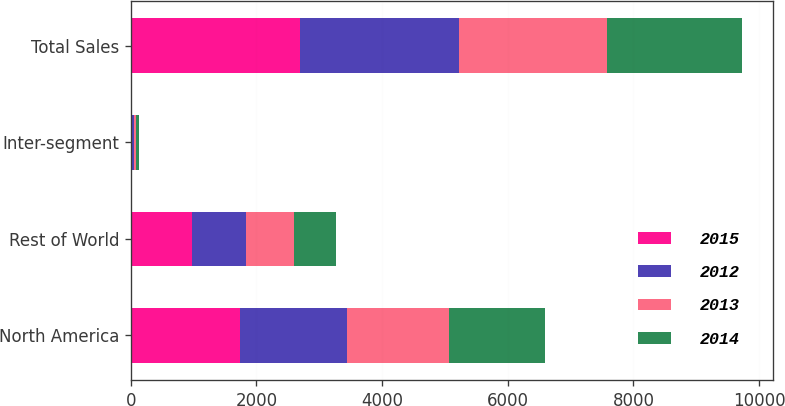Convert chart to OTSL. <chart><loc_0><loc_0><loc_500><loc_500><stacked_bar_chart><ecel><fcel>North America<fcel>Rest of World<fcel>Inter-segment<fcel>Total Sales<nl><fcel>2015<fcel>1743.2<fcel>965.6<fcel>22.9<fcel>2685.9<nl><fcel>2012<fcel>1703<fcel>866.1<fcel>32.6<fcel>2536.5<nl><fcel>2013<fcel>1621.7<fcel>768.3<fcel>34<fcel>2356<nl><fcel>2014<fcel>1520<fcel>668<fcel>34.2<fcel>2153.8<nl></chart> 